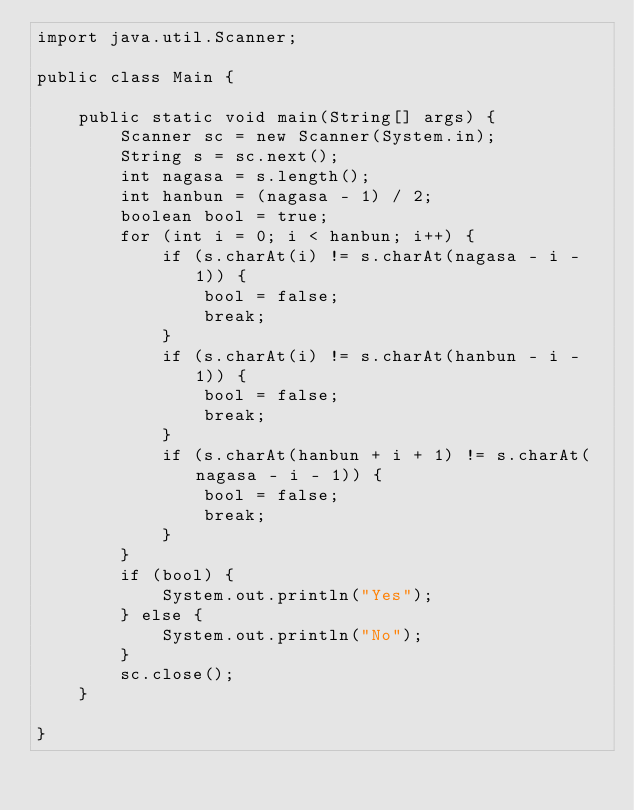Convert code to text. <code><loc_0><loc_0><loc_500><loc_500><_Java_>import java.util.Scanner;

public class Main {

	public static void main(String[] args) {
		Scanner sc = new Scanner(System.in);
		String s = sc.next();
		int nagasa = s.length();
		int hanbun = (nagasa - 1) / 2;
		boolean bool = true;
		for (int i = 0; i < hanbun; i++) {
			if (s.charAt(i) != s.charAt(nagasa - i - 1)) {
				bool = false;
				break;
			}
			if (s.charAt(i) != s.charAt(hanbun - i - 1)) {
				bool = false;
				break;
			}
			if (s.charAt(hanbun + i + 1) != s.charAt(nagasa - i - 1)) {
				bool = false;
				break;
			}
		}
		if (bool) {
			System.out.println("Yes");
		} else {
			System.out.println("No");
		}
		sc.close();
	}

}
</code> 